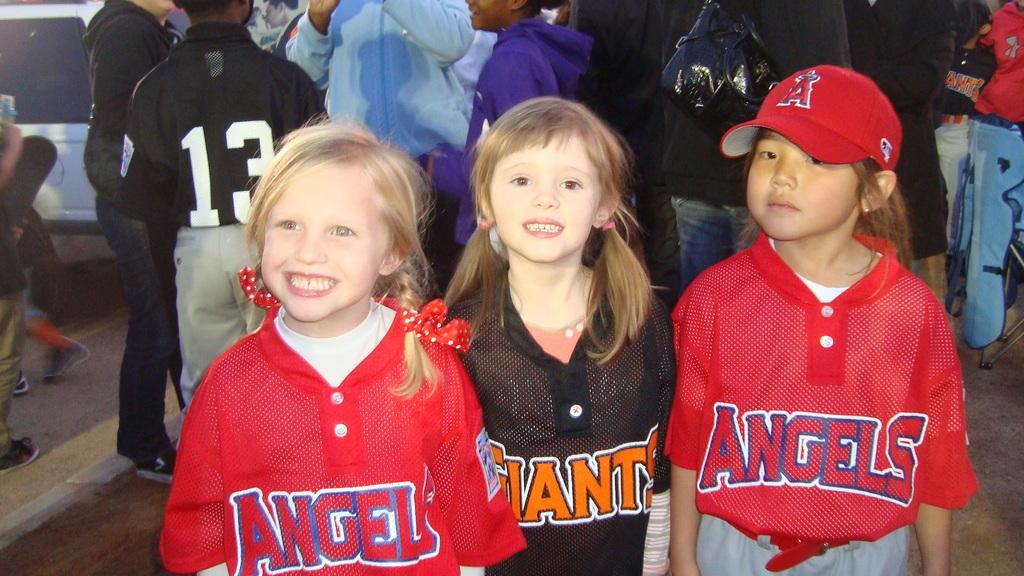Provide a one-sentence caption for the provided image. two children with angle jerseys and one wearing the giants. 